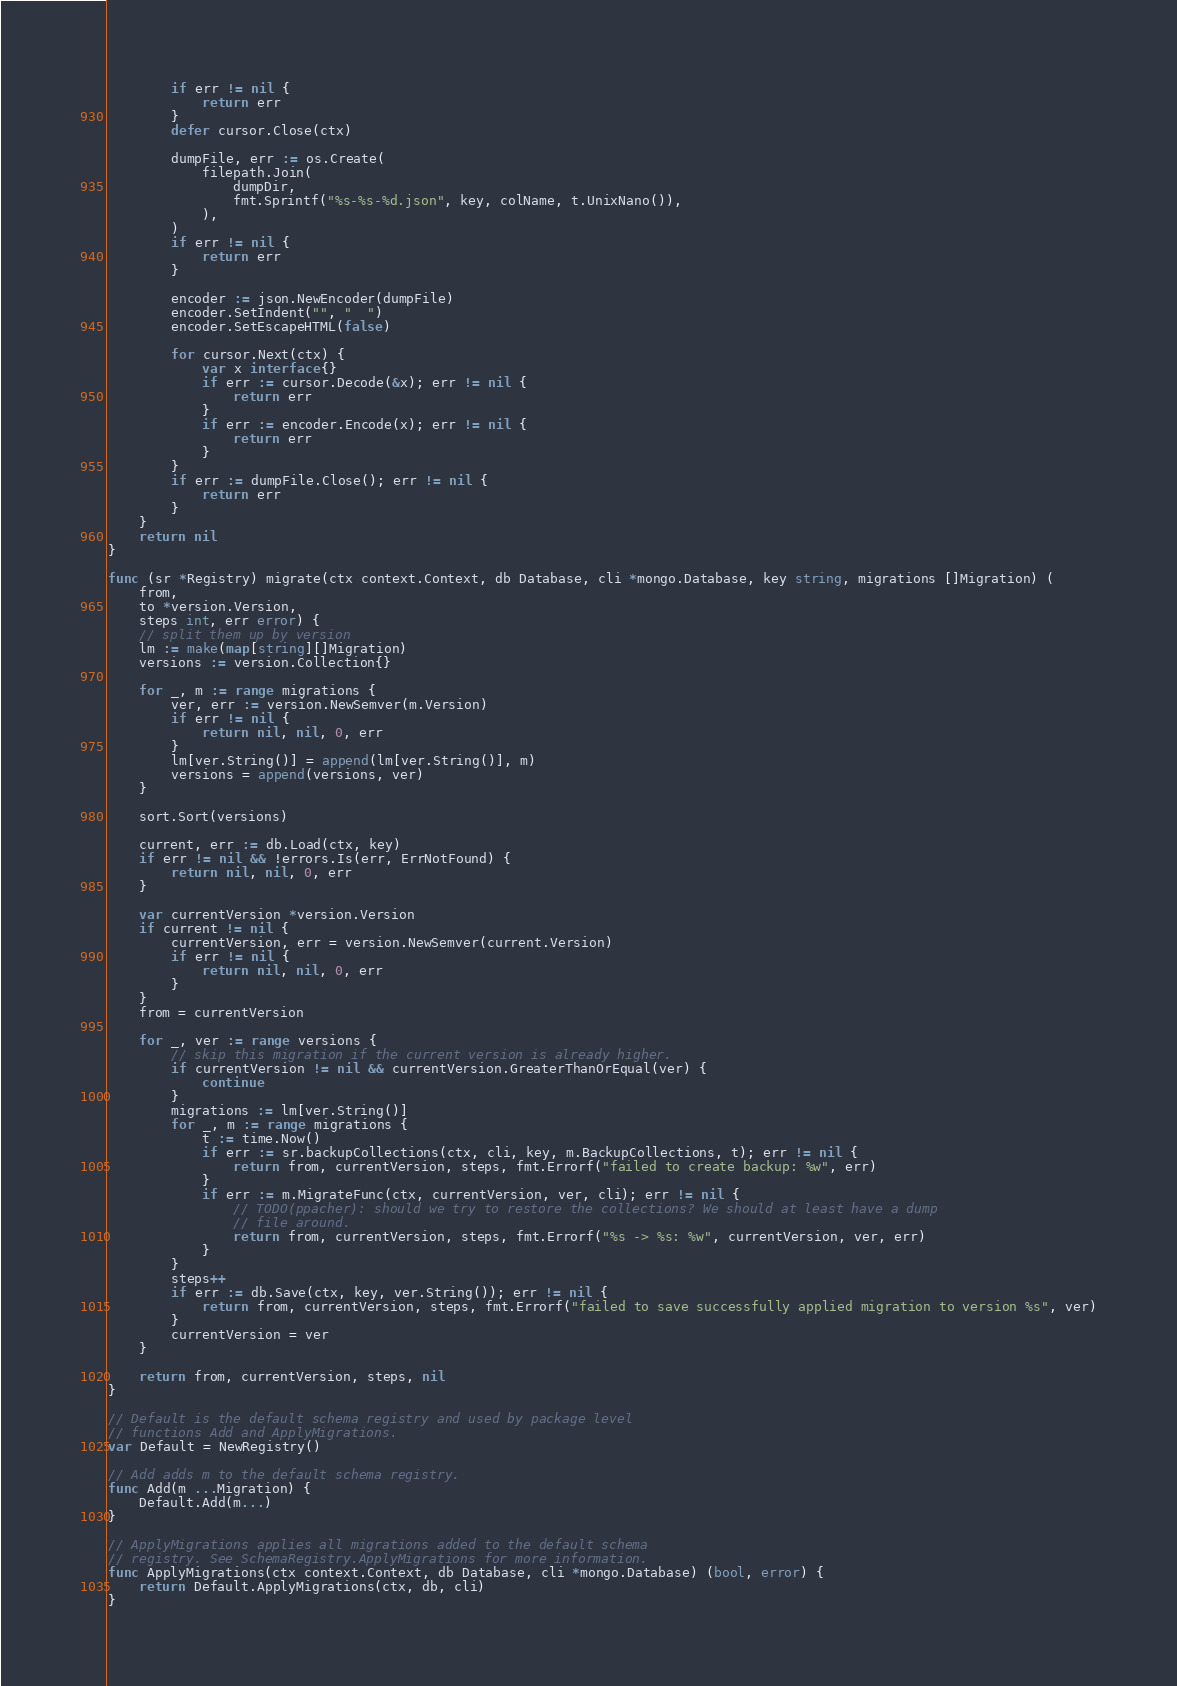<code> <loc_0><loc_0><loc_500><loc_500><_Go_>		if err != nil {
			return err
		}
		defer cursor.Close(ctx)

		dumpFile, err := os.Create(
			filepath.Join(
				dumpDir,
				fmt.Sprintf("%s-%s-%d.json", key, colName, t.UnixNano()),
			),
		)
		if err != nil {
			return err
		}

		encoder := json.NewEncoder(dumpFile)
		encoder.SetIndent("", "  ")
		encoder.SetEscapeHTML(false)

		for cursor.Next(ctx) {
			var x interface{}
			if err := cursor.Decode(&x); err != nil {
				return err
			}
			if err := encoder.Encode(x); err != nil {
				return err
			}
		}
		if err := dumpFile.Close(); err != nil {
			return err
		}
	}
	return nil
}

func (sr *Registry) migrate(ctx context.Context, db Database, cli *mongo.Database, key string, migrations []Migration) (
	from,
	to *version.Version,
	steps int, err error) {
	// split them up by version
	lm := make(map[string][]Migration)
	versions := version.Collection{}

	for _, m := range migrations {
		ver, err := version.NewSemver(m.Version)
		if err != nil {
			return nil, nil, 0, err
		}
		lm[ver.String()] = append(lm[ver.String()], m)
		versions = append(versions, ver)
	}

	sort.Sort(versions)

	current, err := db.Load(ctx, key)
	if err != nil && !errors.Is(err, ErrNotFound) {
		return nil, nil, 0, err
	}

	var currentVersion *version.Version
	if current != nil {
		currentVersion, err = version.NewSemver(current.Version)
		if err != nil {
			return nil, nil, 0, err
		}
	}
	from = currentVersion

	for _, ver := range versions {
		// skip this migration if the current version is already higher.
		if currentVersion != nil && currentVersion.GreaterThanOrEqual(ver) {
			continue
		}
		migrations := lm[ver.String()]
		for _, m := range migrations {
			t := time.Now()
			if err := sr.backupCollections(ctx, cli, key, m.BackupCollections, t); err != nil {
				return from, currentVersion, steps, fmt.Errorf("failed to create backup: %w", err)
			}
			if err := m.MigrateFunc(ctx, currentVersion, ver, cli); err != nil {
				// TODO(ppacher): should we try to restore the collections? We should at least have a dump
				// file around.
				return from, currentVersion, steps, fmt.Errorf("%s -> %s: %w", currentVersion, ver, err)
			}
		}
		steps++
		if err := db.Save(ctx, key, ver.String()); err != nil {
			return from, currentVersion, steps, fmt.Errorf("failed to save successfully applied migration to version %s", ver)
		}
		currentVersion = ver
	}

	return from, currentVersion, steps, nil
}

// Default is the default schema registry and used by package level
// functions Add and ApplyMigrations.
var Default = NewRegistry()

// Add adds m to the default schema registry.
func Add(m ...Migration) {
	Default.Add(m...)
}

// ApplyMigrations applies all migrations added to the default schema
// registry. See SchemaRegistry.ApplyMigrations for more information.
func ApplyMigrations(ctx context.Context, db Database, cli *mongo.Database) (bool, error) {
	return Default.ApplyMigrations(ctx, db, cli)
}
</code> 